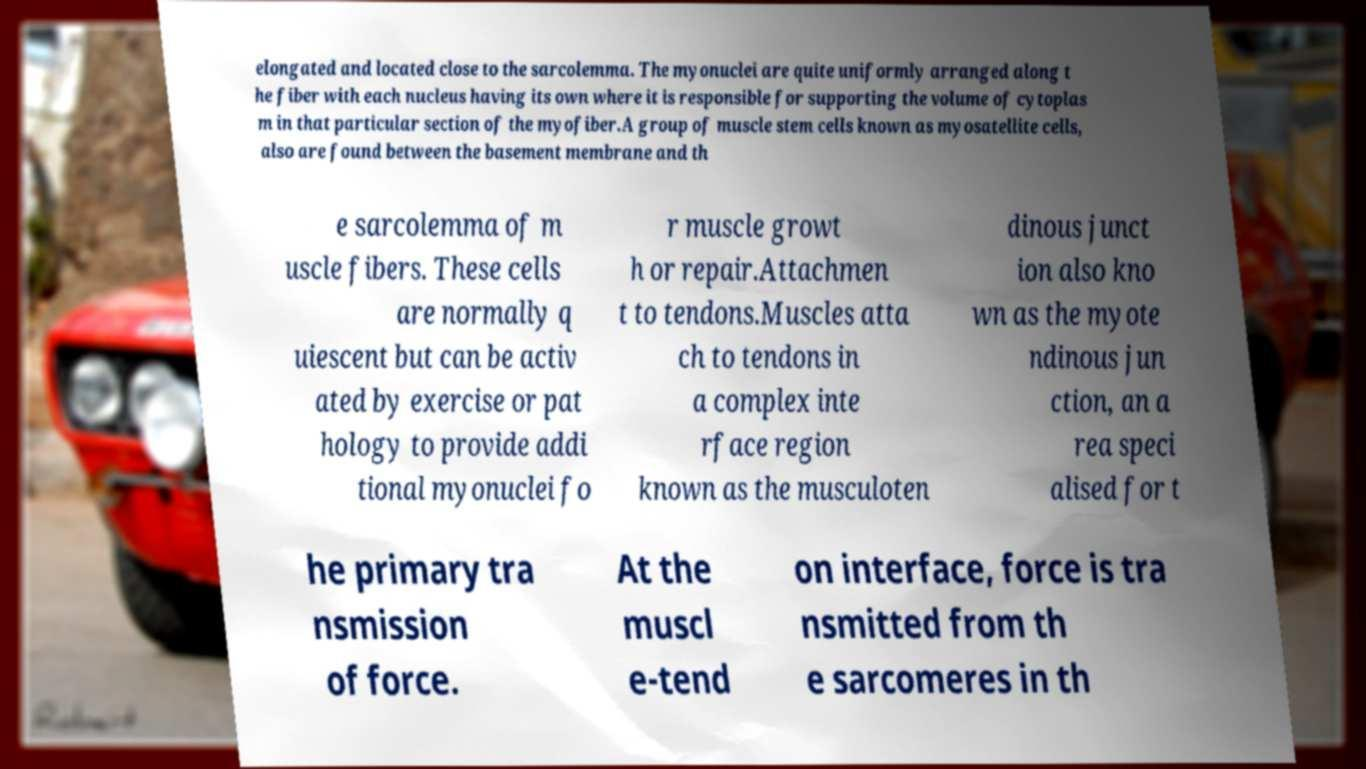I need the written content from this picture converted into text. Can you do that? elongated and located close to the sarcolemma. The myonuclei are quite uniformly arranged along t he fiber with each nucleus having its own where it is responsible for supporting the volume of cytoplas m in that particular section of the myofiber.A group of muscle stem cells known as myosatellite cells, also are found between the basement membrane and th e sarcolemma of m uscle fibers. These cells are normally q uiescent but can be activ ated by exercise or pat hology to provide addi tional myonuclei fo r muscle growt h or repair.Attachmen t to tendons.Muscles atta ch to tendons in a complex inte rface region known as the musculoten dinous junct ion also kno wn as the myote ndinous jun ction, an a rea speci alised for t he primary tra nsmission of force. At the muscl e-tend on interface, force is tra nsmitted from th e sarcomeres in th 